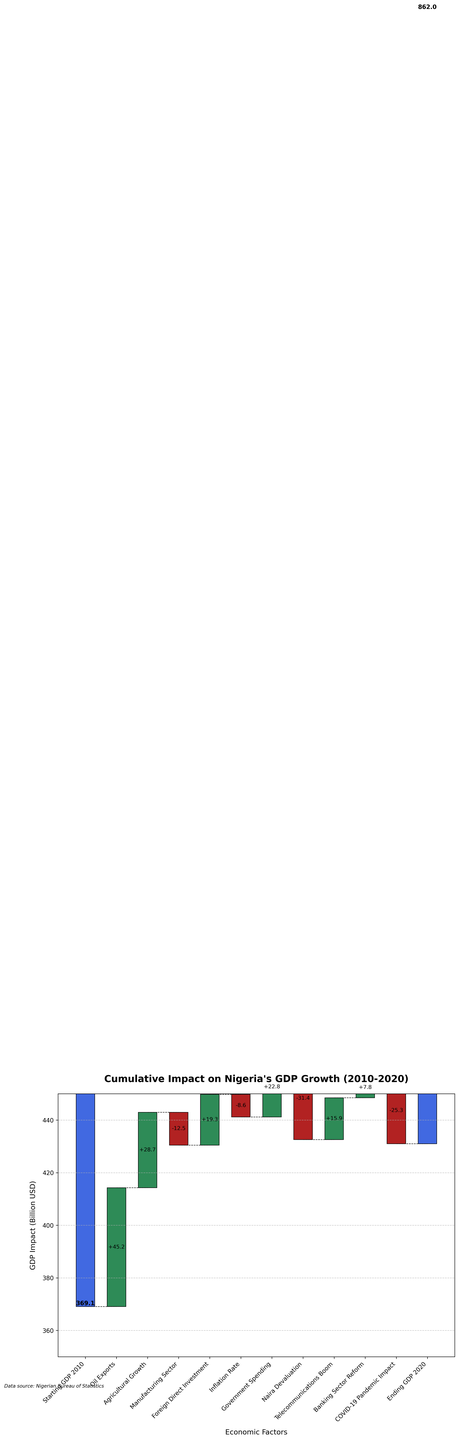What is the title of the figure? The title can be found at the top of the figure, usually in bold or larger font. In this case, the title is "Cumulative Impact on Nigeria's GDP Growth (2010-2020)".
Answer: Cumulative Impact on Nigeria's GDP Growth (2010-2020) What economic factor contributed the most positively to Nigeria's GDP growth? Look for the economic factor with the highest positive value. "Oil Exports" has the highest positive impact of +45.2 billion USD.
Answer: Oil Exports Which economic factor had the largest negative impact on Nigeria's GDP growth? Identify the factor with the highest negative impact. "Naira Devaluation" has the largest negative impact of -31.4 billion USD.
Answer: Naira Devaluation How does the impact of Agricultural Growth compare to Manufacturing Sector? Compare the two values. Agricultural Growth has a positive impact of +28.7 billion USD, while Manufacturing Sector has a negative impact of -12.5 billion USD.
Answer: Agricultural Growth is more positive than Manufacturing Sector What is the net impact of Foreign Direct Investment and Inflation Rate combined? Add the impact of Foreign Direct Investment (+19.3) and subtract the impact of Inflation Rate (-8.6). Combined impact is 19.3 - 8.6 = 10.7 billion USD.
Answer: 10.7 billion USD Did Government Spending have a positive or negative impact on GDP growth? Check the sign of Government Spending's impact. It has a positive impact of +22.8 billion USD.
Answer: Positive What is the overall cumulative impact after Telecommunications Boom? Sum the impacts from the start up to Telecommunications Boom. Start with 369.1, then add 45.2, 28.7, subtract 12.5, add 19.3, subtract 8.6, add 22.8, subtract 31.4, and add 15.9. The cumulative impact is approximately 448.5 billion USD.
Answer: 448.5 billion USD What is the total impact of all positive economic factors combined? Add all the positive impacts together: 45.2 (Oil Exports) + 28.7 (Agricultural Growth) + 19.3 (Foreign Direct Investment) + 22.8 (Government Spending) + 15.9 (Telecommunications Boom) + 7.8 (Banking Sector Reform) = 139.7 billion USD.
Answer: 139.7 billion USD What is the cumulative GDP at the end of 2020? The chart gives the final value directly as "Ending GDP 2020" which is 431.0 billion USD.
Answer: 431.0 billion USD How much did COVID-19 Pandemic Impact affect the GDP relative to the starting GDP? Look at the impact of COVID-19, which is -25.3 billion USD. Compare this to the starting GDP of 369.1 billion USD. The relative impact is roughly -6.85% of the starting GDP.
Answer: -6.85% of starting GDP 